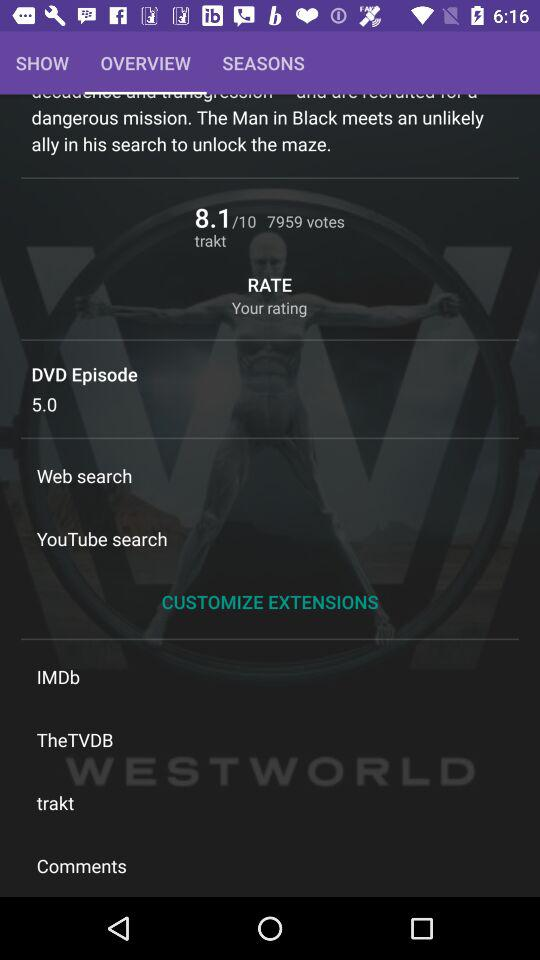What tab is selected? The selected tab is "OVERVIEW". 